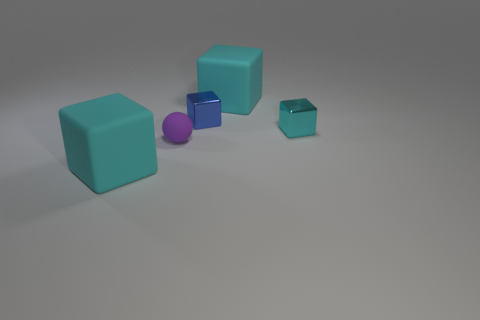Does the rubber ball have the same color as the block that is in front of the small purple sphere?
Offer a terse response. No. What number of objects are either blue metal objects or small gray matte objects?
Give a very brief answer. 1. Is there any other thing that has the same color as the small rubber thing?
Ensure brevity in your answer.  No. Is the material of the tiny cyan block the same as the block in front of the small cyan metallic block?
Your answer should be compact. No. What shape is the small purple matte object behind the block that is in front of the tiny matte thing?
Your answer should be very brief. Sphere. There is a thing that is right of the blue block and behind the cyan metallic object; what is its shape?
Give a very brief answer. Cube. How many objects are either large rubber objects or large objects in front of the small matte sphere?
Make the answer very short. 2. What is the material of the other small thing that is the same shape as the blue object?
Your response must be concise. Metal. There is a cyan object that is in front of the tiny blue metal object and to the right of the tiny purple rubber ball; what material is it?
Ensure brevity in your answer.  Metal. How many other purple things are the same shape as the tiny purple thing?
Your answer should be very brief. 0. 